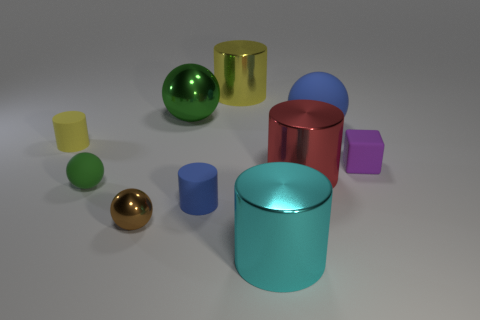Subtract all yellow cubes. How many yellow cylinders are left? 2 Subtract all brown balls. How many balls are left? 3 Subtract 2 spheres. How many spheres are left? 2 Subtract all red metallic cylinders. How many cylinders are left? 4 Subtract all cyan balls. Subtract all yellow cylinders. How many balls are left? 4 Subtract all cubes. How many objects are left? 9 Subtract 0 blue cubes. How many objects are left? 10 Subtract all large cyan metal cylinders. Subtract all large cyan cylinders. How many objects are left? 8 Add 8 small cylinders. How many small cylinders are left? 10 Add 3 balls. How many balls exist? 7 